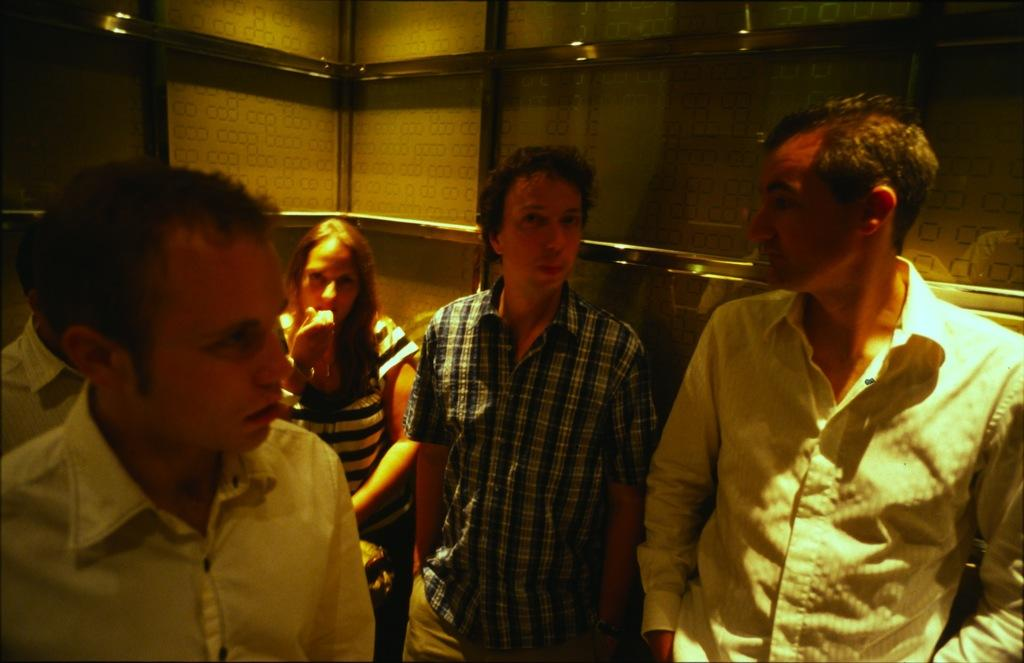How many people are in the image? There are persons standing in the image. Can you describe the background of the image? There are two walls visible in the background of the image. What type of wood can be seen on the stage in the image? There is no stage or wood present in the image; it only features persons standing and two walls in the background. 